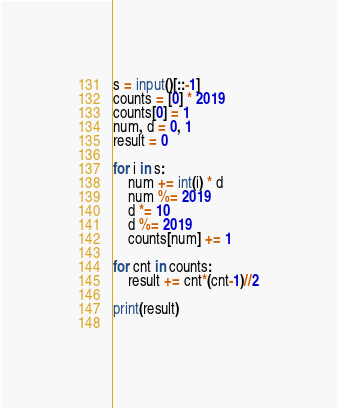<code> <loc_0><loc_0><loc_500><loc_500><_Python_>s = input()[::-1]
counts = [0] * 2019
counts[0] = 1
num, d = 0, 1
result = 0

for i in s:
    num += int(i) * d
    num %= 2019
    d *= 10
    d %= 2019
    counts[num] += 1
    
for cnt in counts:
    result += cnt*(cnt-1)//2
    
print(result)
    </code> 